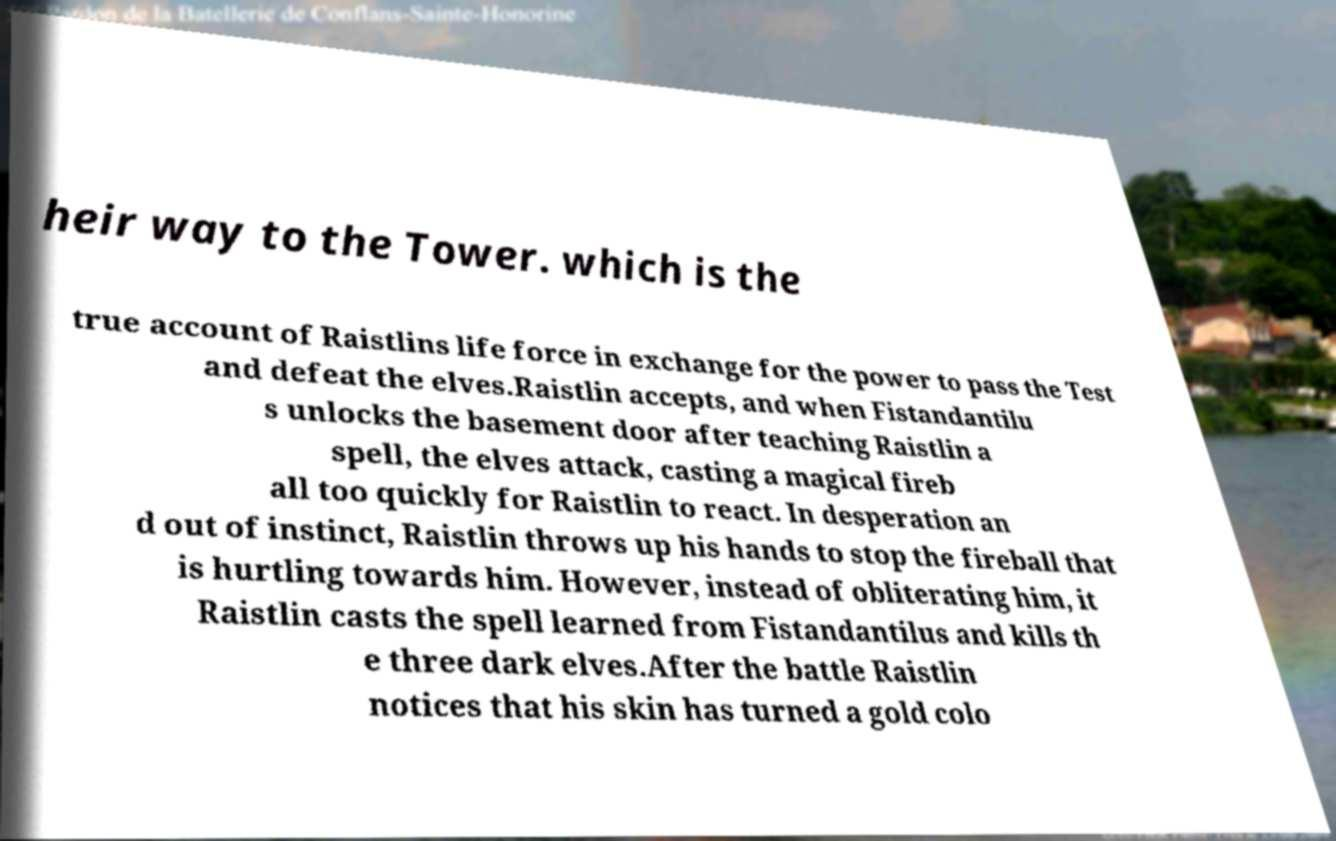Can you read and provide the text displayed in the image?This photo seems to have some interesting text. Can you extract and type it out for me? heir way to the Tower. which is the true account of Raistlins life force in exchange for the power to pass the Test and defeat the elves.Raistlin accepts, and when Fistandantilu s unlocks the basement door after teaching Raistlin a spell, the elves attack, casting a magical fireb all too quickly for Raistlin to react. In desperation an d out of instinct, Raistlin throws up his hands to stop the fireball that is hurtling towards him. However, instead of obliterating him, it Raistlin casts the spell learned from Fistandantilus and kills th e three dark elves.After the battle Raistlin notices that his skin has turned a gold colo 